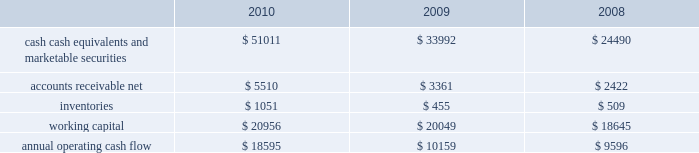Table of contents primarily to certain undistributed foreign earnings for which no u.s .
Taxes are provided because such earnings are intended to be indefinitely reinvested outside the u.s .
The lower effective tax rate in 2010 as compared to 2009 is due primarily to an increase in foreign earnings on which u.s .
Income taxes have not been provided as such earnings are intended to be indefinitely reinvested outside the u.s .
As of september 25 , 2010 , the company had deferred tax assets arising from deductible temporary differences , tax losses , and tax credits of $ 2.4 billion , and deferred tax liabilities of $ 5.0 billion .
Management believes it is more likely than not that forecasted income , including income that may be generated as a result of certain tax planning strategies , together with future reversals of existing taxable temporary differences , will be sufficient to fully recover the deferred tax assets .
The company will continue to evaluate the realizability of deferred tax assets quarterly by assessing the need for and amount of a valuation allowance .
The internal revenue service ( the 201cirs 201d ) has completed its field audit of the company 2019s federal income tax returns for the years 2004 through 2006 and proposed certain adjustments .
The company has contested certain of these adjustments through the irs appeals office .
The irs is currently examining the years 2007 through 2009 .
All irs audit issues for years prior to 2004 have been resolved .
During the third quarter of 2010 , the company reached a tax settlement with the irs for the years 2002 through 2003 .
In addition , the company is subject to audits by state , local , and foreign tax authorities .
Management believes that adequate provision has been made for any adjustments that may result from tax examinations .
However , the outcome of tax audits cannot be predicted with certainty .
If any issues addressed in the company 2019s tax audits are resolved in a manner not consistent with management 2019s expectations , the company could be required to adjust its provision for income taxes in the period such resolution occurs .
Liquidity and capital resources the table presents selected financial information and statistics as of and for the three years ended september 25 , 2010 ( in millions ) : as of september 25 , 2010 , the company had $ 51 billion in cash , cash equivalents and marketable securities , an increase of $ 17 billion from september 26 , 2009 .
The principal component of this net increase was the cash generated by operating activities of $ 18.6 billion , which was partially offset by payments for acquisition of property , plant and equipment of $ 2 billion and payments made in connection with business acquisitions , net of cash acquired , of $ 638 million .
The company 2019s marketable securities investment portfolio is invested primarily in highly rated securities , generally with a minimum rating of single-a or equivalent .
As of september 25 , 2010 and september 26 , 2009 , $ 30.8 billion and $ 17.4 billion , respectively , of the company 2019s cash , cash equivalents and marketable securities were held by foreign subsidiaries and are generally based in u.s .
Dollar-denominated holdings .
The company believes its existing balances of cash , cash equivalents and marketable securities will be sufficient to satisfy its working capital needs , capital asset purchases , outstanding commitments and other liquidity requirements associated with its existing operations over the next 12 months. .

How much did cash cash equivalents and marketable securities increase from 2008 to 2010? 
Computations: ((51011 - 24490) / 24490)
Answer: 1.08293. 